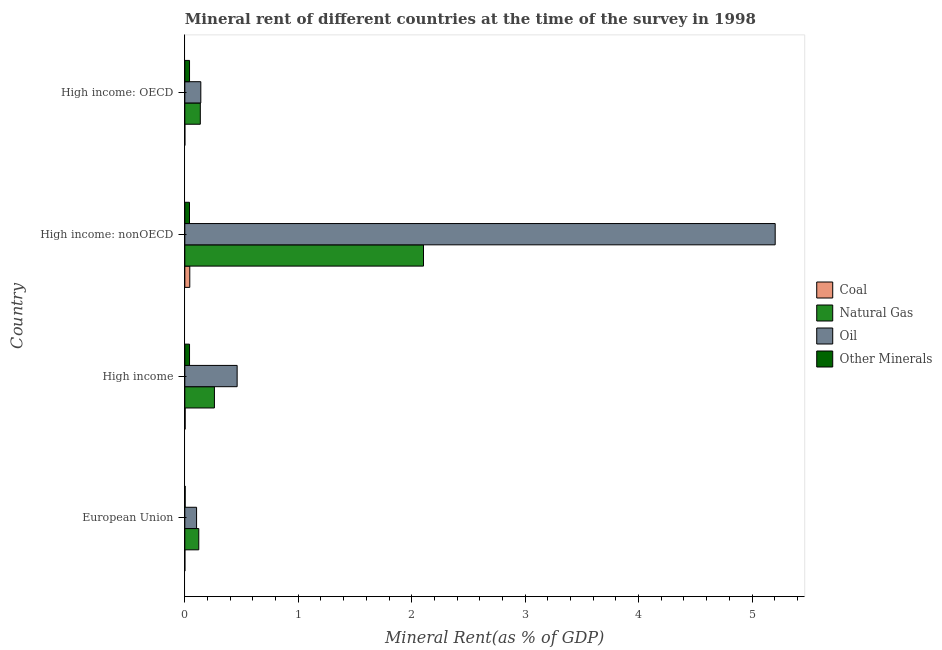How many different coloured bars are there?
Provide a succinct answer. 4. Are the number of bars per tick equal to the number of legend labels?
Make the answer very short. Yes. What is the label of the 1st group of bars from the top?
Offer a terse response. High income: OECD. In how many cases, is the number of bars for a given country not equal to the number of legend labels?
Your response must be concise. 0. What is the natural gas rent in European Union?
Your answer should be compact. 0.12. Across all countries, what is the maximum oil rent?
Make the answer very short. 5.2. Across all countries, what is the minimum natural gas rent?
Provide a short and direct response. 0.12. In which country was the natural gas rent maximum?
Provide a short and direct response. High income: nonOECD. In which country was the natural gas rent minimum?
Provide a short and direct response. European Union. What is the total  rent of other minerals in the graph?
Your answer should be very brief. 0.13. What is the difference between the  rent of other minerals in High income and that in High income: OECD?
Your response must be concise. -0. What is the difference between the coal rent in High income and the  rent of other minerals in European Union?
Provide a succinct answer. -6.266017722417107e-5. What is the average  rent of other minerals per country?
Provide a succinct answer. 0.03. What is the difference between the natural gas rent and coal rent in High income?
Your response must be concise. 0.26. In how many countries, is the  rent of other minerals greater than 1.2 %?
Your answer should be compact. 0. What is the difference between the highest and the second highest oil rent?
Offer a very short reply. 4.74. What is the difference between the highest and the lowest oil rent?
Your answer should be compact. 5.1. Is the sum of the  rent of other minerals in European Union and High income: OECD greater than the maximum natural gas rent across all countries?
Provide a short and direct response. No. Is it the case that in every country, the sum of the natural gas rent and oil rent is greater than the sum of  rent of other minerals and coal rent?
Offer a very short reply. Yes. What does the 3rd bar from the top in High income represents?
Provide a short and direct response. Natural Gas. What does the 4th bar from the bottom in High income: OECD represents?
Your response must be concise. Other Minerals. Is it the case that in every country, the sum of the coal rent and natural gas rent is greater than the oil rent?
Provide a short and direct response. No. Are all the bars in the graph horizontal?
Give a very brief answer. Yes. How many countries are there in the graph?
Give a very brief answer. 4. What is the difference between two consecutive major ticks on the X-axis?
Provide a short and direct response. 1. Are the values on the major ticks of X-axis written in scientific E-notation?
Your answer should be very brief. No. Does the graph contain any zero values?
Your answer should be very brief. No. How many legend labels are there?
Keep it short and to the point. 4. What is the title of the graph?
Offer a very short reply. Mineral rent of different countries at the time of the survey in 1998. Does "Agriculture" appear as one of the legend labels in the graph?
Provide a short and direct response. No. What is the label or title of the X-axis?
Provide a succinct answer. Mineral Rent(as % of GDP). What is the Mineral Rent(as % of GDP) in Coal in European Union?
Offer a very short reply. 0. What is the Mineral Rent(as % of GDP) in Natural Gas in European Union?
Your answer should be very brief. 0.12. What is the Mineral Rent(as % of GDP) in Oil in European Union?
Give a very brief answer. 0.1. What is the Mineral Rent(as % of GDP) of Other Minerals in European Union?
Ensure brevity in your answer.  0. What is the Mineral Rent(as % of GDP) in Coal in High income?
Ensure brevity in your answer.  0. What is the Mineral Rent(as % of GDP) of Natural Gas in High income?
Ensure brevity in your answer.  0.26. What is the Mineral Rent(as % of GDP) in Oil in High income?
Your answer should be compact. 0.46. What is the Mineral Rent(as % of GDP) of Other Minerals in High income?
Make the answer very short. 0.04. What is the Mineral Rent(as % of GDP) in Coal in High income: nonOECD?
Provide a short and direct response. 0.04. What is the Mineral Rent(as % of GDP) in Natural Gas in High income: nonOECD?
Your response must be concise. 2.1. What is the Mineral Rent(as % of GDP) of Oil in High income: nonOECD?
Your answer should be compact. 5.2. What is the Mineral Rent(as % of GDP) of Other Minerals in High income: nonOECD?
Your response must be concise. 0.04. What is the Mineral Rent(as % of GDP) of Coal in High income: OECD?
Your response must be concise. 6.0945704561912e-5. What is the Mineral Rent(as % of GDP) of Natural Gas in High income: OECD?
Your response must be concise. 0.14. What is the Mineral Rent(as % of GDP) in Oil in High income: OECD?
Keep it short and to the point. 0.14. What is the Mineral Rent(as % of GDP) of Other Minerals in High income: OECD?
Your answer should be compact. 0.04. Across all countries, what is the maximum Mineral Rent(as % of GDP) of Coal?
Offer a very short reply. 0.04. Across all countries, what is the maximum Mineral Rent(as % of GDP) of Natural Gas?
Ensure brevity in your answer.  2.1. Across all countries, what is the maximum Mineral Rent(as % of GDP) in Oil?
Your answer should be compact. 5.2. Across all countries, what is the maximum Mineral Rent(as % of GDP) in Other Minerals?
Offer a terse response. 0.04. Across all countries, what is the minimum Mineral Rent(as % of GDP) in Coal?
Your response must be concise. 6.0945704561912e-5. Across all countries, what is the minimum Mineral Rent(as % of GDP) of Natural Gas?
Provide a short and direct response. 0.12. Across all countries, what is the minimum Mineral Rent(as % of GDP) of Oil?
Your answer should be very brief. 0.1. Across all countries, what is the minimum Mineral Rent(as % of GDP) in Other Minerals?
Make the answer very short. 0. What is the total Mineral Rent(as % of GDP) in Coal in the graph?
Provide a succinct answer. 0.05. What is the total Mineral Rent(as % of GDP) of Natural Gas in the graph?
Keep it short and to the point. 2.62. What is the total Mineral Rent(as % of GDP) in Oil in the graph?
Your answer should be compact. 5.91. What is the total Mineral Rent(as % of GDP) in Other Minerals in the graph?
Make the answer very short. 0.13. What is the difference between the Mineral Rent(as % of GDP) in Coal in European Union and that in High income?
Provide a succinct answer. -0. What is the difference between the Mineral Rent(as % of GDP) in Natural Gas in European Union and that in High income?
Give a very brief answer. -0.14. What is the difference between the Mineral Rent(as % of GDP) in Oil in European Union and that in High income?
Your answer should be very brief. -0.36. What is the difference between the Mineral Rent(as % of GDP) in Other Minerals in European Union and that in High income?
Keep it short and to the point. -0.04. What is the difference between the Mineral Rent(as % of GDP) in Coal in European Union and that in High income: nonOECD?
Provide a succinct answer. -0.04. What is the difference between the Mineral Rent(as % of GDP) of Natural Gas in European Union and that in High income: nonOECD?
Provide a succinct answer. -1.98. What is the difference between the Mineral Rent(as % of GDP) in Oil in European Union and that in High income: nonOECD?
Your answer should be very brief. -5.1. What is the difference between the Mineral Rent(as % of GDP) in Other Minerals in European Union and that in High income: nonOECD?
Offer a very short reply. -0.04. What is the difference between the Mineral Rent(as % of GDP) in Natural Gas in European Union and that in High income: OECD?
Your answer should be compact. -0.01. What is the difference between the Mineral Rent(as % of GDP) in Oil in European Union and that in High income: OECD?
Provide a short and direct response. -0.04. What is the difference between the Mineral Rent(as % of GDP) of Other Minerals in European Union and that in High income: OECD?
Make the answer very short. -0.04. What is the difference between the Mineral Rent(as % of GDP) in Coal in High income and that in High income: nonOECD?
Give a very brief answer. -0.04. What is the difference between the Mineral Rent(as % of GDP) in Natural Gas in High income and that in High income: nonOECD?
Give a very brief answer. -1.84. What is the difference between the Mineral Rent(as % of GDP) in Oil in High income and that in High income: nonOECD?
Ensure brevity in your answer.  -4.74. What is the difference between the Mineral Rent(as % of GDP) of Coal in High income and that in High income: OECD?
Your answer should be compact. 0. What is the difference between the Mineral Rent(as % of GDP) of Natural Gas in High income and that in High income: OECD?
Keep it short and to the point. 0.12. What is the difference between the Mineral Rent(as % of GDP) of Oil in High income and that in High income: OECD?
Make the answer very short. 0.32. What is the difference between the Mineral Rent(as % of GDP) of Coal in High income: nonOECD and that in High income: OECD?
Your answer should be compact. 0.04. What is the difference between the Mineral Rent(as % of GDP) of Natural Gas in High income: nonOECD and that in High income: OECD?
Keep it short and to the point. 1.97. What is the difference between the Mineral Rent(as % of GDP) in Oil in High income: nonOECD and that in High income: OECD?
Offer a very short reply. 5.06. What is the difference between the Mineral Rent(as % of GDP) of Other Minerals in High income: nonOECD and that in High income: OECD?
Ensure brevity in your answer.  -0. What is the difference between the Mineral Rent(as % of GDP) of Coal in European Union and the Mineral Rent(as % of GDP) of Natural Gas in High income?
Make the answer very short. -0.26. What is the difference between the Mineral Rent(as % of GDP) in Coal in European Union and the Mineral Rent(as % of GDP) in Oil in High income?
Keep it short and to the point. -0.46. What is the difference between the Mineral Rent(as % of GDP) of Coal in European Union and the Mineral Rent(as % of GDP) of Other Minerals in High income?
Keep it short and to the point. -0.04. What is the difference between the Mineral Rent(as % of GDP) of Natural Gas in European Union and the Mineral Rent(as % of GDP) of Oil in High income?
Provide a succinct answer. -0.34. What is the difference between the Mineral Rent(as % of GDP) of Natural Gas in European Union and the Mineral Rent(as % of GDP) of Other Minerals in High income?
Offer a very short reply. 0.08. What is the difference between the Mineral Rent(as % of GDP) of Oil in European Union and the Mineral Rent(as % of GDP) of Other Minerals in High income?
Ensure brevity in your answer.  0.06. What is the difference between the Mineral Rent(as % of GDP) in Coal in European Union and the Mineral Rent(as % of GDP) in Natural Gas in High income: nonOECD?
Make the answer very short. -2.1. What is the difference between the Mineral Rent(as % of GDP) in Coal in European Union and the Mineral Rent(as % of GDP) in Oil in High income: nonOECD?
Offer a terse response. -5.2. What is the difference between the Mineral Rent(as % of GDP) of Coal in European Union and the Mineral Rent(as % of GDP) of Other Minerals in High income: nonOECD?
Provide a short and direct response. -0.04. What is the difference between the Mineral Rent(as % of GDP) of Natural Gas in European Union and the Mineral Rent(as % of GDP) of Oil in High income: nonOECD?
Keep it short and to the point. -5.08. What is the difference between the Mineral Rent(as % of GDP) in Natural Gas in European Union and the Mineral Rent(as % of GDP) in Other Minerals in High income: nonOECD?
Offer a terse response. 0.08. What is the difference between the Mineral Rent(as % of GDP) of Oil in European Union and the Mineral Rent(as % of GDP) of Other Minerals in High income: nonOECD?
Provide a succinct answer. 0.06. What is the difference between the Mineral Rent(as % of GDP) of Coal in European Union and the Mineral Rent(as % of GDP) of Natural Gas in High income: OECD?
Make the answer very short. -0.14. What is the difference between the Mineral Rent(as % of GDP) in Coal in European Union and the Mineral Rent(as % of GDP) in Oil in High income: OECD?
Provide a short and direct response. -0.14. What is the difference between the Mineral Rent(as % of GDP) of Coal in European Union and the Mineral Rent(as % of GDP) of Other Minerals in High income: OECD?
Offer a terse response. -0.04. What is the difference between the Mineral Rent(as % of GDP) in Natural Gas in European Union and the Mineral Rent(as % of GDP) in Oil in High income: OECD?
Keep it short and to the point. -0.02. What is the difference between the Mineral Rent(as % of GDP) in Natural Gas in European Union and the Mineral Rent(as % of GDP) in Other Minerals in High income: OECD?
Your response must be concise. 0.08. What is the difference between the Mineral Rent(as % of GDP) in Oil in European Union and the Mineral Rent(as % of GDP) in Other Minerals in High income: OECD?
Provide a short and direct response. 0.06. What is the difference between the Mineral Rent(as % of GDP) of Coal in High income and the Mineral Rent(as % of GDP) of Natural Gas in High income: nonOECD?
Keep it short and to the point. -2.1. What is the difference between the Mineral Rent(as % of GDP) in Coal in High income and the Mineral Rent(as % of GDP) in Oil in High income: nonOECD?
Your answer should be compact. -5.2. What is the difference between the Mineral Rent(as % of GDP) in Coal in High income and the Mineral Rent(as % of GDP) in Other Minerals in High income: nonOECD?
Offer a terse response. -0.04. What is the difference between the Mineral Rent(as % of GDP) of Natural Gas in High income and the Mineral Rent(as % of GDP) of Oil in High income: nonOECD?
Ensure brevity in your answer.  -4.94. What is the difference between the Mineral Rent(as % of GDP) in Natural Gas in High income and the Mineral Rent(as % of GDP) in Other Minerals in High income: nonOECD?
Provide a succinct answer. 0.22. What is the difference between the Mineral Rent(as % of GDP) of Oil in High income and the Mineral Rent(as % of GDP) of Other Minerals in High income: nonOECD?
Your answer should be compact. 0.42. What is the difference between the Mineral Rent(as % of GDP) in Coal in High income and the Mineral Rent(as % of GDP) in Natural Gas in High income: OECD?
Your response must be concise. -0.13. What is the difference between the Mineral Rent(as % of GDP) of Coal in High income and the Mineral Rent(as % of GDP) of Oil in High income: OECD?
Your response must be concise. -0.14. What is the difference between the Mineral Rent(as % of GDP) of Coal in High income and the Mineral Rent(as % of GDP) of Other Minerals in High income: OECD?
Ensure brevity in your answer.  -0.04. What is the difference between the Mineral Rent(as % of GDP) of Natural Gas in High income and the Mineral Rent(as % of GDP) of Oil in High income: OECD?
Your answer should be compact. 0.12. What is the difference between the Mineral Rent(as % of GDP) in Natural Gas in High income and the Mineral Rent(as % of GDP) in Other Minerals in High income: OECD?
Your answer should be compact. 0.22. What is the difference between the Mineral Rent(as % of GDP) in Oil in High income and the Mineral Rent(as % of GDP) in Other Minerals in High income: OECD?
Ensure brevity in your answer.  0.42. What is the difference between the Mineral Rent(as % of GDP) in Coal in High income: nonOECD and the Mineral Rent(as % of GDP) in Natural Gas in High income: OECD?
Your answer should be very brief. -0.09. What is the difference between the Mineral Rent(as % of GDP) of Coal in High income: nonOECD and the Mineral Rent(as % of GDP) of Oil in High income: OECD?
Give a very brief answer. -0.1. What is the difference between the Mineral Rent(as % of GDP) in Coal in High income: nonOECD and the Mineral Rent(as % of GDP) in Other Minerals in High income: OECD?
Provide a short and direct response. 0. What is the difference between the Mineral Rent(as % of GDP) in Natural Gas in High income: nonOECD and the Mineral Rent(as % of GDP) in Oil in High income: OECD?
Provide a succinct answer. 1.96. What is the difference between the Mineral Rent(as % of GDP) of Natural Gas in High income: nonOECD and the Mineral Rent(as % of GDP) of Other Minerals in High income: OECD?
Provide a short and direct response. 2.06. What is the difference between the Mineral Rent(as % of GDP) in Oil in High income: nonOECD and the Mineral Rent(as % of GDP) in Other Minerals in High income: OECD?
Give a very brief answer. 5.16. What is the average Mineral Rent(as % of GDP) in Coal per country?
Your answer should be very brief. 0.01. What is the average Mineral Rent(as % of GDP) in Natural Gas per country?
Offer a very short reply. 0.66. What is the average Mineral Rent(as % of GDP) of Oil per country?
Make the answer very short. 1.48. What is the average Mineral Rent(as % of GDP) of Other Minerals per country?
Make the answer very short. 0.03. What is the difference between the Mineral Rent(as % of GDP) in Coal and Mineral Rent(as % of GDP) in Natural Gas in European Union?
Provide a succinct answer. -0.12. What is the difference between the Mineral Rent(as % of GDP) of Coal and Mineral Rent(as % of GDP) of Oil in European Union?
Give a very brief answer. -0.1. What is the difference between the Mineral Rent(as % of GDP) of Coal and Mineral Rent(as % of GDP) of Other Minerals in European Union?
Your response must be concise. -0. What is the difference between the Mineral Rent(as % of GDP) in Natural Gas and Mineral Rent(as % of GDP) in Oil in European Union?
Make the answer very short. 0.02. What is the difference between the Mineral Rent(as % of GDP) of Natural Gas and Mineral Rent(as % of GDP) of Other Minerals in European Union?
Your response must be concise. 0.12. What is the difference between the Mineral Rent(as % of GDP) of Oil and Mineral Rent(as % of GDP) of Other Minerals in European Union?
Your answer should be very brief. 0.1. What is the difference between the Mineral Rent(as % of GDP) in Coal and Mineral Rent(as % of GDP) in Natural Gas in High income?
Your response must be concise. -0.26. What is the difference between the Mineral Rent(as % of GDP) of Coal and Mineral Rent(as % of GDP) of Oil in High income?
Your answer should be compact. -0.46. What is the difference between the Mineral Rent(as % of GDP) of Coal and Mineral Rent(as % of GDP) of Other Minerals in High income?
Your answer should be compact. -0.04. What is the difference between the Mineral Rent(as % of GDP) of Natural Gas and Mineral Rent(as % of GDP) of Oil in High income?
Make the answer very short. -0.2. What is the difference between the Mineral Rent(as % of GDP) of Natural Gas and Mineral Rent(as % of GDP) of Other Minerals in High income?
Your answer should be compact. 0.22. What is the difference between the Mineral Rent(as % of GDP) in Oil and Mineral Rent(as % of GDP) in Other Minerals in High income?
Ensure brevity in your answer.  0.42. What is the difference between the Mineral Rent(as % of GDP) of Coal and Mineral Rent(as % of GDP) of Natural Gas in High income: nonOECD?
Provide a succinct answer. -2.06. What is the difference between the Mineral Rent(as % of GDP) in Coal and Mineral Rent(as % of GDP) in Oil in High income: nonOECD?
Your response must be concise. -5.16. What is the difference between the Mineral Rent(as % of GDP) of Coal and Mineral Rent(as % of GDP) of Other Minerals in High income: nonOECD?
Your answer should be compact. 0. What is the difference between the Mineral Rent(as % of GDP) in Natural Gas and Mineral Rent(as % of GDP) in Oil in High income: nonOECD?
Ensure brevity in your answer.  -3.1. What is the difference between the Mineral Rent(as % of GDP) in Natural Gas and Mineral Rent(as % of GDP) in Other Minerals in High income: nonOECD?
Your answer should be compact. 2.06. What is the difference between the Mineral Rent(as % of GDP) in Oil and Mineral Rent(as % of GDP) in Other Minerals in High income: nonOECD?
Offer a terse response. 5.16. What is the difference between the Mineral Rent(as % of GDP) in Coal and Mineral Rent(as % of GDP) in Natural Gas in High income: OECD?
Your answer should be compact. -0.14. What is the difference between the Mineral Rent(as % of GDP) in Coal and Mineral Rent(as % of GDP) in Oil in High income: OECD?
Your answer should be compact. -0.14. What is the difference between the Mineral Rent(as % of GDP) in Coal and Mineral Rent(as % of GDP) in Other Minerals in High income: OECD?
Ensure brevity in your answer.  -0.04. What is the difference between the Mineral Rent(as % of GDP) in Natural Gas and Mineral Rent(as % of GDP) in Oil in High income: OECD?
Offer a very short reply. -0. What is the difference between the Mineral Rent(as % of GDP) in Natural Gas and Mineral Rent(as % of GDP) in Other Minerals in High income: OECD?
Offer a terse response. 0.1. What is the difference between the Mineral Rent(as % of GDP) of Oil and Mineral Rent(as % of GDP) of Other Minerals in High income: OECD?
Ensure brevity in your answer.  0.1. What is the ratio of the Mineral Rent(as % of GDP) in Coal in European Union to that in High income?
Your answer should be very brief. 0.06. What is the ratio of the Mineral Rent(as % of GDP) of Natural Gas in European Union to that in High income?
Your answer should be very brief. 0.47. What is the ratio of the Mineral Rent(as % of GDP) of Oil in European Union to that in High income?
Your response must be concise. 0.22. What is the ratio of the Mineral Rent(as % of GDP) of Other Minerals in European Union to that in High income?
Your answer should be very brief. 0.07. What is the ratio of the Mineral Rent(as % of GDP) in Coal in European Union to that in High income: nonOECD?
Your response must be concise. 0. What is the ratio of the Mineral Rent(as % of GDP) in Natural Gas in European Union to that in High income: nonOECD?
Provide a succinct answer. 0.06. What is the ratio of the Mineral Rent(as % of GDP) of Oil in European Union to that in High income: nonOECD?
Make the answer very short. 0.02. What is the ratio of the Mineral Rent(as % of GDP) in Other Minerals in European Union to that in High income: nonOECD?
Keep it short and to the point. 0.07. What is the ratio of the Mineral Rent(as % of GDP) in Coal in European Union to that in High income: OECD?
Your answer should be compact. 2.58. What is the ratio of the Mineral Rent(as % of GDP) of Natural Gas in European Union to that in High income: OECD?
Ensure brevity in your answer.  0.9. What is the ratio of the Mineral Rent(as % of GDP) of Oil in European Union to that in High income: OECD?
Offer a very short reply. 0.73. What is the ratio of the Mineral Rent(as % of GDP) of Other Minerals in European Union to that in High income: OECD?
Offer a terse response. 0.07. What is the ratio of the Mineral Rent(as % of GDP) of Coal in High income to that in High income: nonOECD?
Keep it short and to the point. 0.06. What is the ratio of the Mineral Rent(as % of GDP) in Natural Gas in High income to that in High income: nonOECD?
Your answer should be very brief. 0.12. What is the ratio of the Mineral Rent(as % of GDP) of Oil in High income to that in High income: nonOECD?
Your answer should be compact. 0.09. What is the ratio of the Mineral Rent(as % of GDP) in Coal in High income to that in High income: OECD?
Make the answer very short. 46.2. What is the ratio of the Mineral Rent(as % of GDP) of Natural Gas in High income to that in High income: OECD?
Make the answer very short. 1.91. What is the ratio of the Mineral Rent(as % of GDP) in Oil in High income to that in High income: OECD?
Your answer should be very brief. 3.27. What is the ratio of the Mineral Rent(as % of GDP) in Other Minerals in High income to that in High income: OECD?
Your response must be concise. 1. What is the ratio of the Mineral Rent(as % of GDP) of Coal in High income: nonOECD to that in High income: OECD?
Ensure brevity in your answer.  715.76. What is the ratio of the Mineral Rent(as % of GDP) of Natural Gas in High income: nonOECD to that in High income: OECD?
Keep it short and to the point. 15.41. What is the ratio of the Mineral Rent(as % of GDP) of Oil in High income: nonOECD to that in High income: OECD?
Your answer should be compact. 36.92. What is the ratio of the Mineral Rent(as % of GDP) of Other Minerals in High income: nonOECD to that in High income: OECD?
Provide a succinct answer. 0.99. What is the difference between the highest and the second highest Mineral Rent(as % of GDP) in Coal?
Your answer should be compact. 0.04. What is the difference between the highest and the second highest Mineral Rent(as % of GDP) of Natural Gas?
Provide a short and direct response. 1.84. What is the difference between the highest and the second highest Mineral Rent(as % of GDP) of Oil?
Offer a very short reply. 4.74. What is the difference between the highest and the lowest Mineral Rent(as % of GDP) in Coal?
Make the answer very short. 0.04. What is the difference between the highest and the lowest Mineral Rent(as % of GDP) of Natural Gas?
Your answer should be compact. 1.98. What is the difference between the highest and the lowest Mineral Rent(as % of GDP) in Oil?
Keep it short and to the point. 5.1. What is the difference between the highest and the lowest Mineral Rent(as % of GDP) of Other Minerals?
Your answer should be compact. 0.04. 